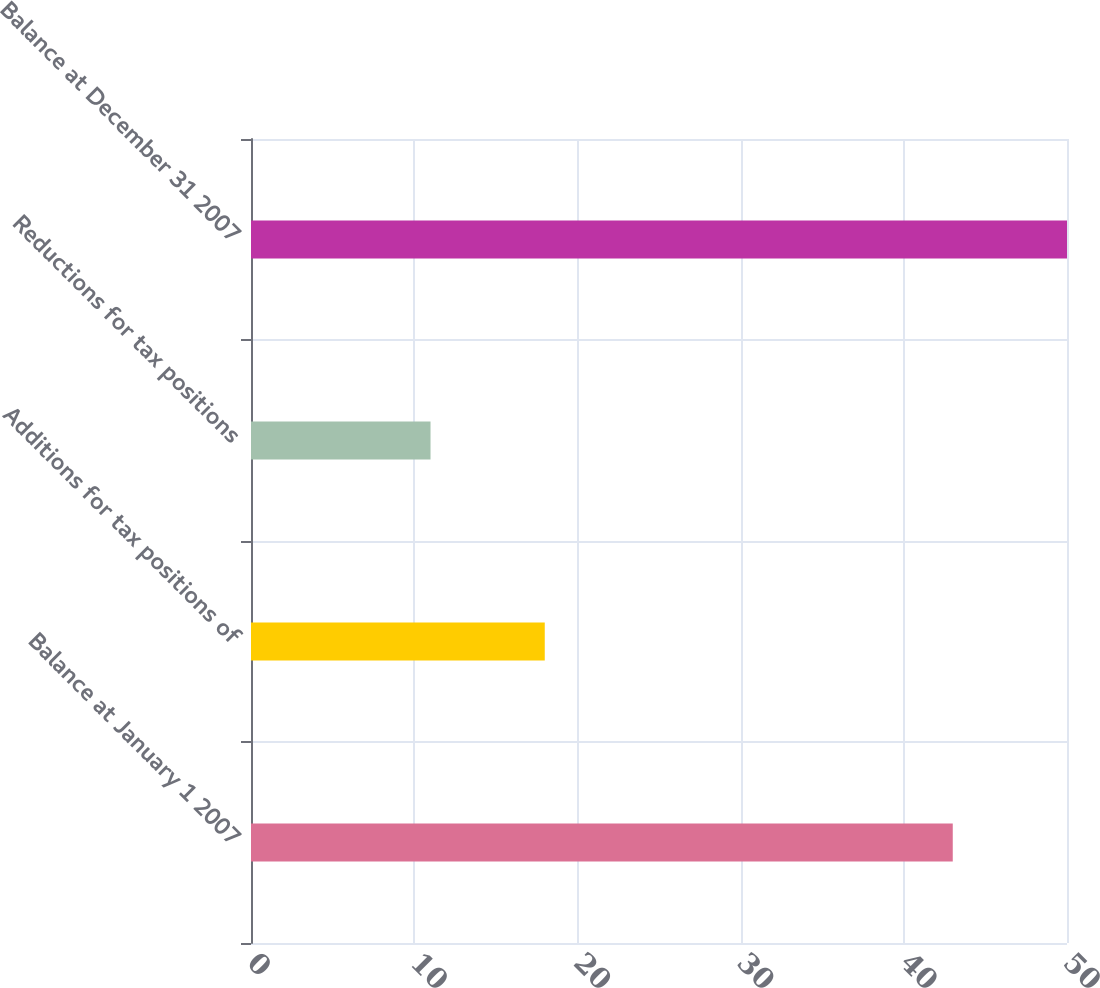<chart> <loc_0><loc_0><loc_500><loc_500><bar_chart><fcel>Balance at January 1 2007<fcel>Additions for tax positions of<fcel>Reductions for tax positions<fcel>Balance at December 31 2007<nl><fcel>43<fcel>18<fcel>11<fcel>50<nl></chart> 